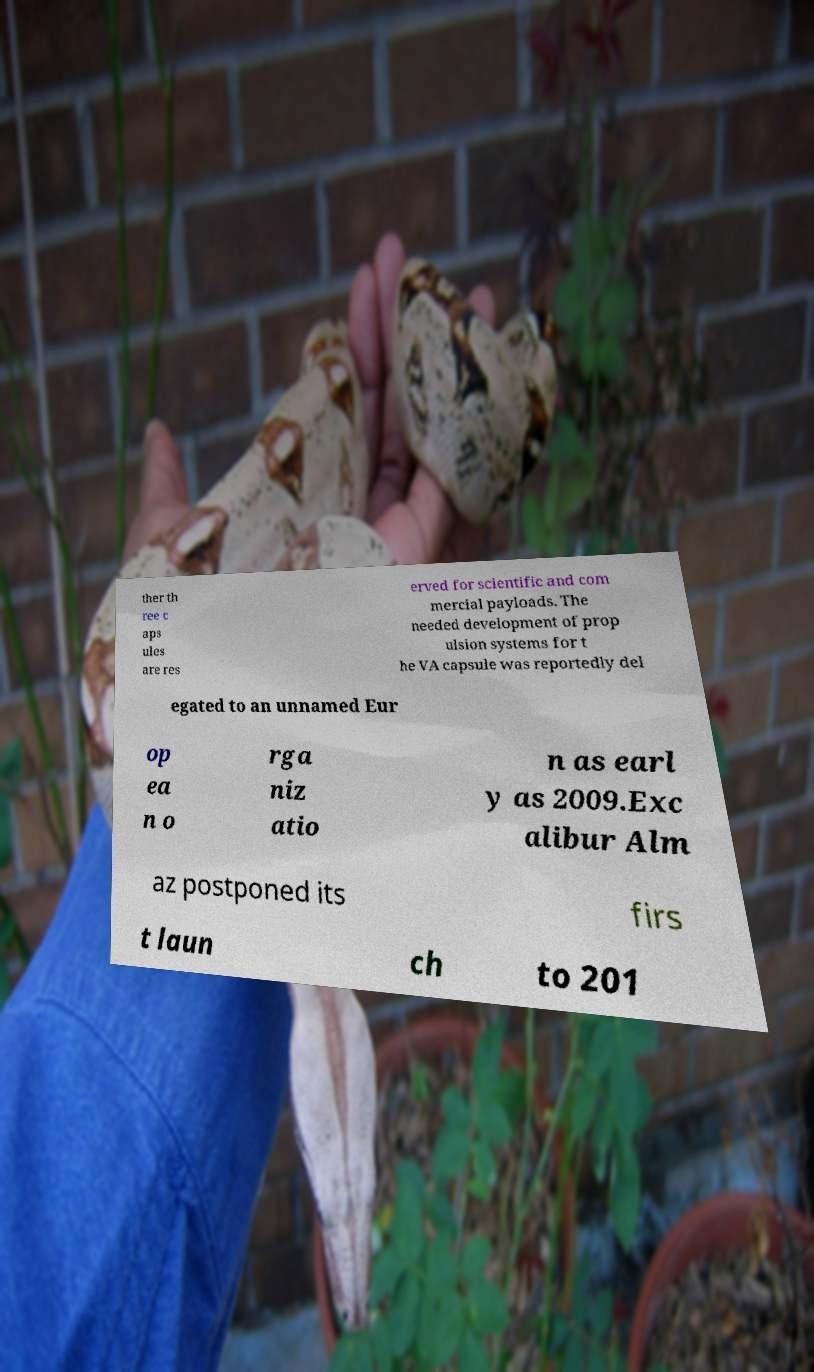What messages or text are displayed in this image? I need them in a readable, typed format. ther th ree c aps ules are res erved for scientific and com mercial payloads. The needed development of prop ulsion systems for t he VA capsule was reportedly del egated to an unnamed Eur op ea n o rga niz atio n as earl y as 2009.Exc alibur Alm az postponed its firs t laun ch to 201 